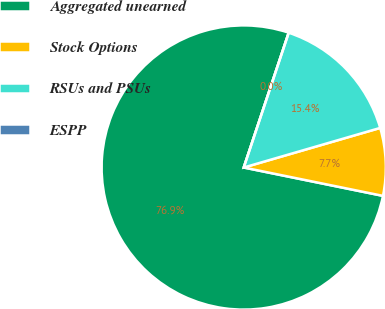Convert chart. <chart><loc_0><loc_0><loc_500><loc_500><pie_chart><fcel>Aggregated unearned<fcel>Stock Options<fcel>RSUs and PSUs<fcel>ESPP<nl><fcel>76.92%<fcel>7.69%<fcel>15.38%<fcel>0.0%<nl></chart> 